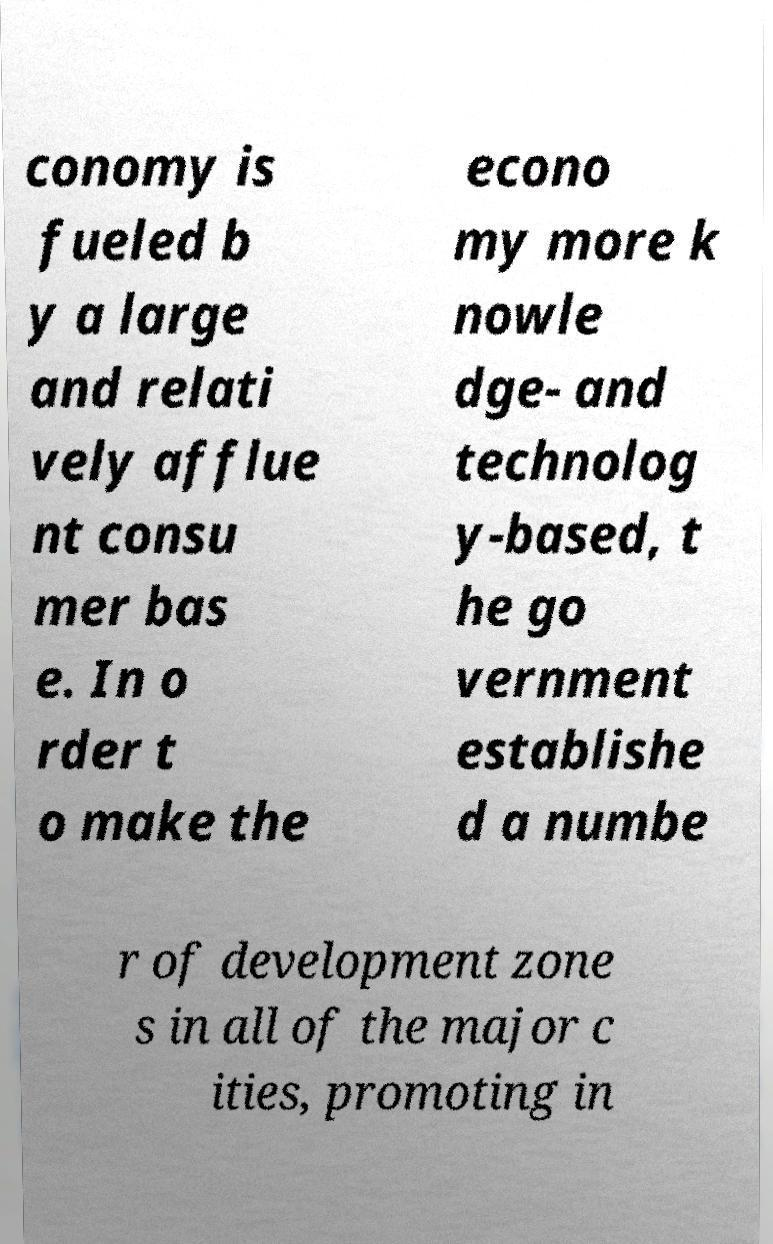What messages or text are displayed in this image? I need them in a readable, typed format. conomy is fueled b y a large and relati vely afflue nt consu mer bas e. In o rder t o make the econo my more k nowle dge- and technolog y-based, t he go vernment establishe d a numbe r of development zone s in all of the major c ities, promoting in 